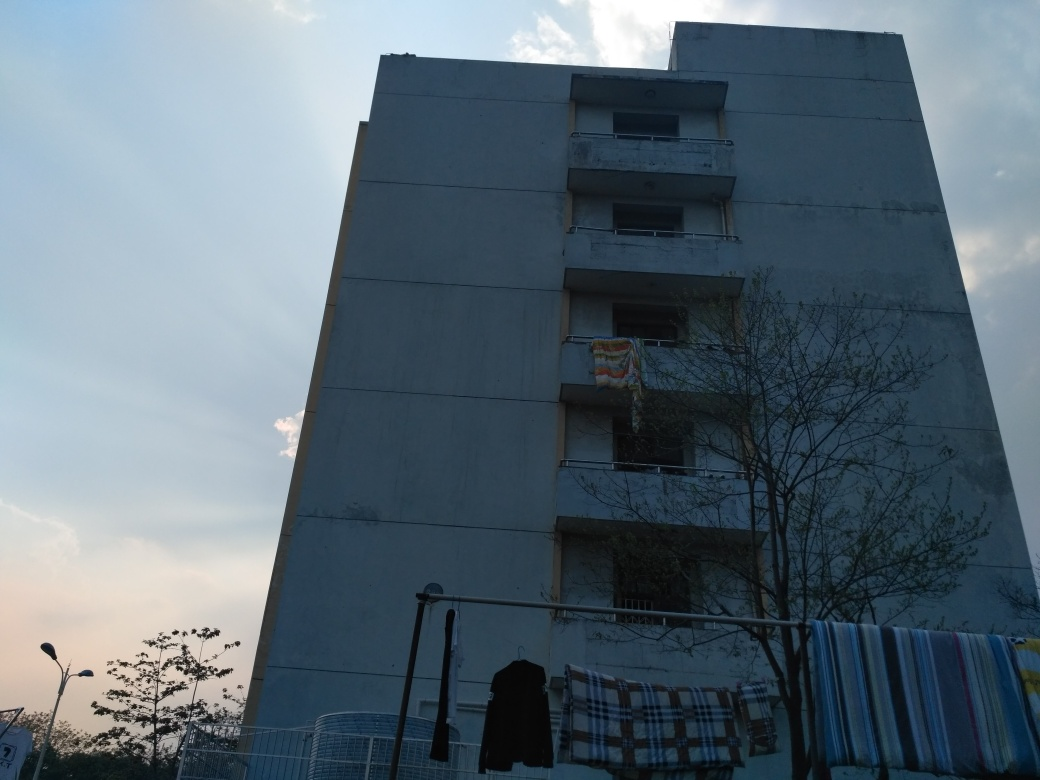What can we infer about the building's location and its environment? The building appears to be located in a residential area. The presence of items like clothes hung out to dry indicates it is a living space. The tree in the foreground and the open sky suggest there might be open areas or possibly a park nearby, contributing to an urban yet possibly communal setting. Does the building's architecture tell us anything about the climate or region? While specific architectural styles can point to certain climatic adaptations, there isn't enough distinctiveness in this building's design to conclusively determine the climate or region. However, the flat façade and protective barriers on the balconies may suggest a need to shield against harsh weather conditions like strong winds or heavy rains. 